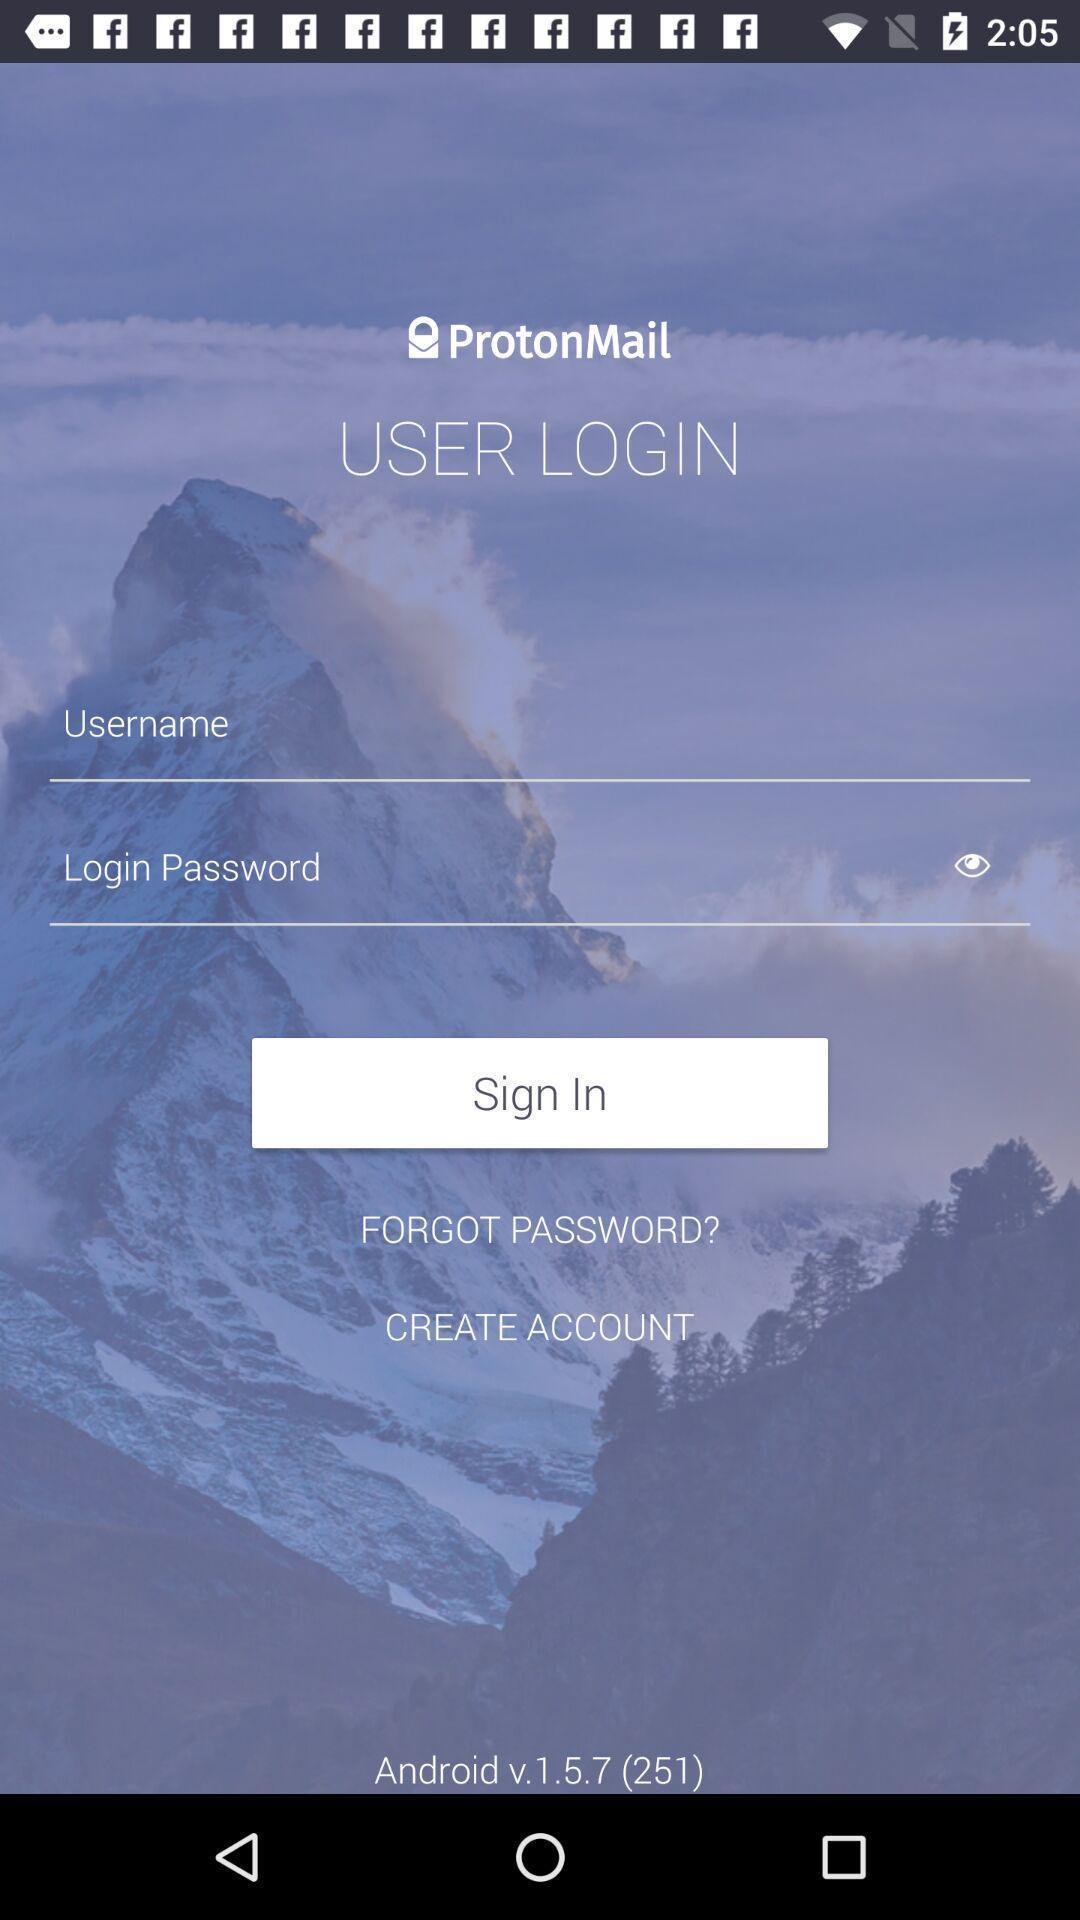Provide a textual representation of this image. Sign in page displayed. 